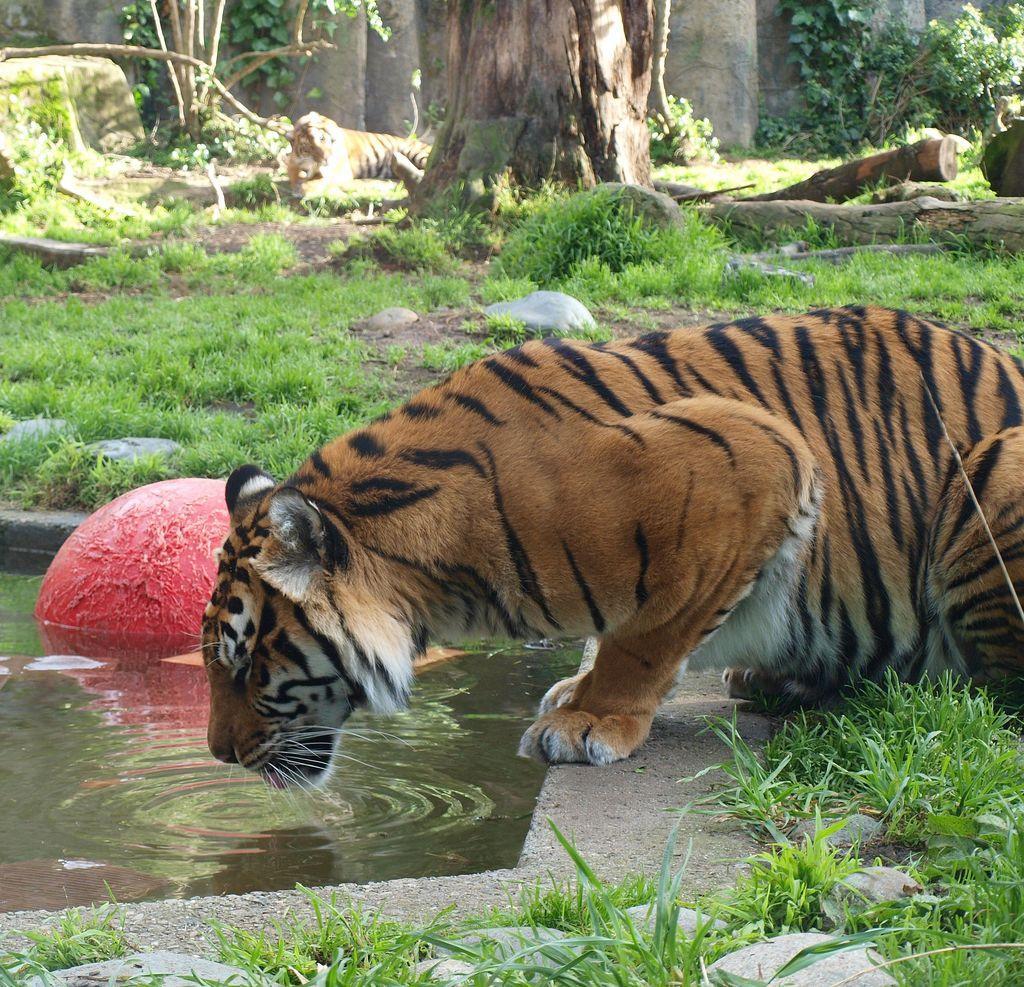Could you give a brief overview of what you see in this image? In this image there is a tiger drinking water in the pond, beside that there are so many stones, grass and trees where we can see there is another tiger sitting under the tree. 